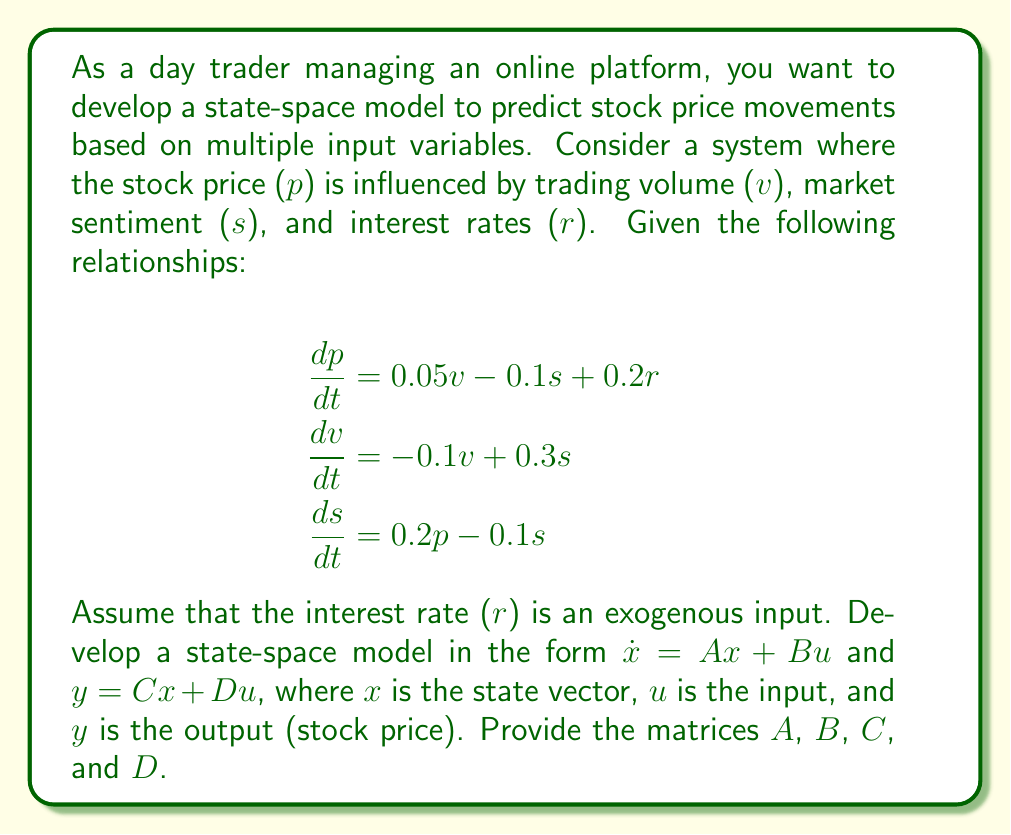Solve this math problem. To develop the state-space model, we need to follow these steps:

1. Identify the state variables, input, and output:
   - State variables: x = [p, v, s]^T (stock price, trading volume, market sentiment)
   - Input: u = r (interest rate)
   - Output: y = p (stock price)

2. Rewrite the differential equations in matrix form:

$$\begin{bmatrix} \dot{p} \\ \dot{v} \\ \dot{s} \end{bmatrix} = 
\begin{bmatrix} 
0 & 0.05 & -0.1 \\
0 & -0.1 & 0.3 \\
0.2 & 0 & -0.1
\end{bmatrix}
\begin{bmatrix} p \\ v \\ s \end{bmatrix} +
\begin{bmatrix} 0.2 \\ 0 \\ 0 \end{bmatrix} r$$

3. Identify the matrices A and B:

$$A = \begin{bmatrix} 
0 & 0.05 & -0.1 \\
0 & -0.1 & 0.3 \\
0.2 & 0 & -0.1
\end{bmatrix}$$

$$B = \begin{bmatrix} 0.2 \\ 0 \\ 0 \end{bmatrix}$$

4. Define the output equation:
   Since the output is the stock price (p), which is the first state variable, we have:

$$y = \begin{bmatrix} 1 & 0 & 0 \end{bmatrix} \begin{bmatrix} p \\ v \\ s \end{bmatrix} + 0 \cdot r$$

5. Identify the matrices C and D:

$$C = \begin{bmatrix} 1 & 0 & 0 \end{bmatrix}$$

$$D = \begin{bmatrix} 0 \end{bmatrix}$$

Thus, we have derived the state-space model in the form:

$$\dot{x} = Ax + Bu$$
$$y = Cx + Du$$

where x = [p, v, s]^T, u = r, and y = p.
Answer: The state-space model is:

$$A = \begin{bmatrix} 
0 & 0.05 & -0.1 \\
0 & -0.1 & 0.3 \\
0.2 & 0 & -0.1
\end{bmatrix}$$

$$B = \begin{bmatrix} 0.2 \\ 0 \\ 0 \end{bmatrix}$$

$$C = \begin{bmatrix} 1 & 0 & 0 \end{bmatrix}$$

$$D = \begin{bmatrix} 0 \end{bmatrix}$$ 